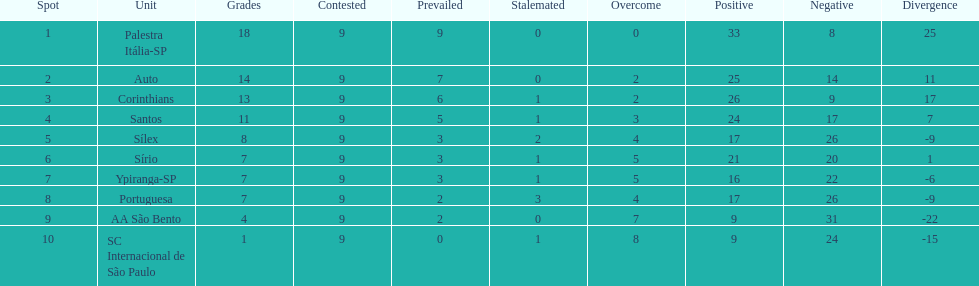How many teams had more points than silex? 4. 